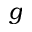<formula> <loc_0><loc_0><loc_500><loc_500>g</formula> 